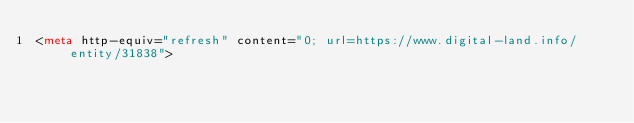<code> <loc_0><loc_0><loc_500><loc_500><_HTML_><meta http-equiv="refresh" content="0; url=https://www.digital-land.info/entity/31838"></code> 